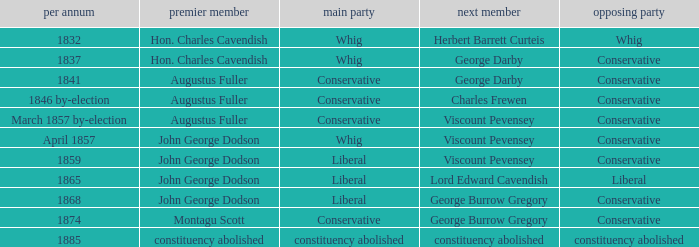In 1865, what was the first party? Liberal. 